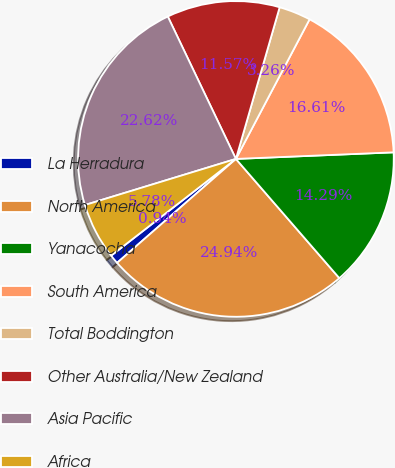<chart> <loc_0><loc_0><loc_500><loc_500><pie_chart><fcel>La Herradura<fcel>North America<fcel>Yanacocha<fcel>South America<fcel>Total Boddington<fcel>Other Australia/New Zealand<fcel>Asia Pacific<fcel>Africa<nl><fcel>0.94%<fcel>24.94%<fcel>14.29%<fcel>16.61%<fcel>3.26%<fcel>11.57%<fcel>22.62%<fcel>5.78%<nl></chart> 